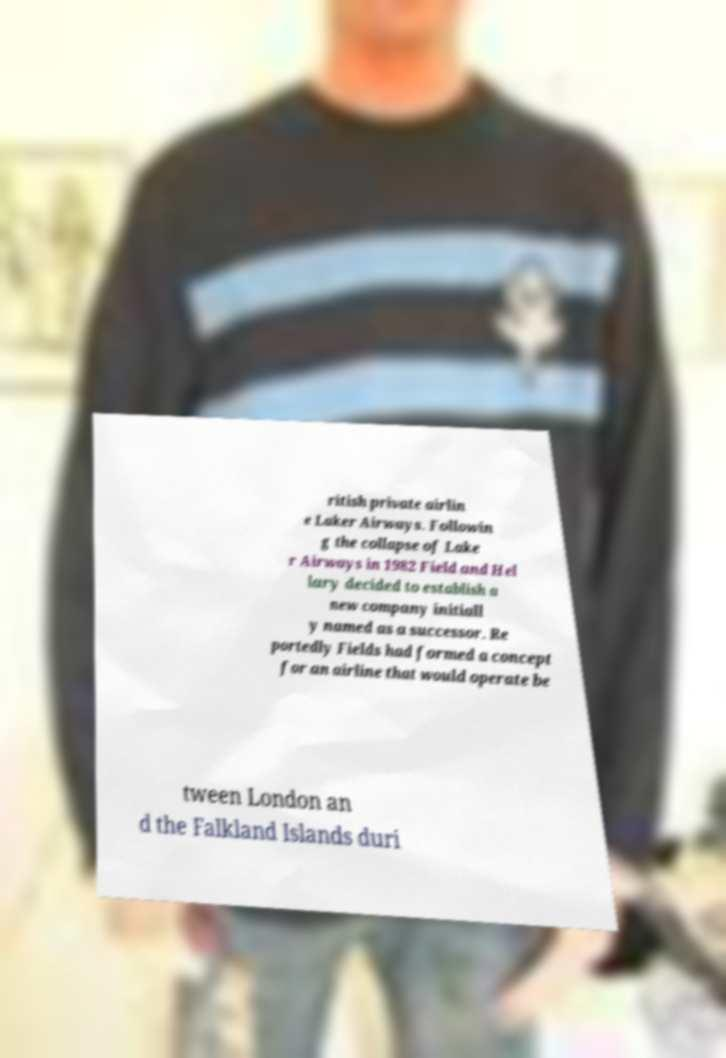For documentation purposes, I need the text within this image transcribed. Could you provide that? ritish private airlin e Laker Airways. Followin g the collapse of Lake r Airways in 1982 Field and Hel lary decided to establish a new company initiall y named as a successor. Re portedly Fields had formed a concept for an airline that would operate be tween London an d the Falkland Islands duri 